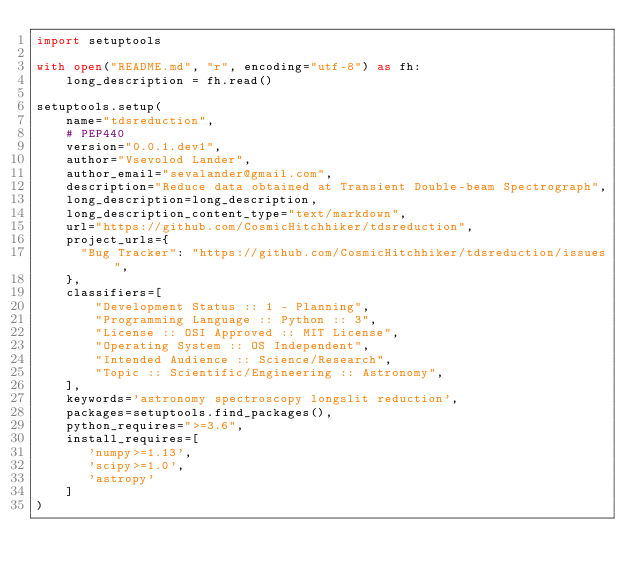<code> <loc_0><loc_0><loc_500><loc_500><_Python_>import setuptools

with open("README.md", "r", encoding="utf-8") as fh:
    long_description = fh.read()

setuptools.setup(
    name="tdsreduction",
    # PEP440
    version="0.0.1.dev1",
    author="Vsevolod Lander",
    author_email="sevalander@gmail.com",
    description="Reduce data obtained at Transient Double-beam Spectrograph",
    long_description=long_description,
    long_description_content_type="text/markdown",
    url="https://github.com/CosmicHitchhiker/tdsreduction",
    project_urls={
      "Bug Tracker": "https://github.com/CosmicHitchhiker/tdsreduction/issues",
    },
    classifiers=[
        "Development Status :: 1 - Planning",
        "Programming Language :: Python :: 3",
        "License :: OSI Approved :: MIT License",
        "Operating System :: OS Independent",
        "Intended Audience :: Science/Research",
        "Topic :: Scientific/Engineering :: Astronomy",
    ],
    keywords='astronomy spectroscopy longslit reduction',
    packages=setuptools.find_packages(),
    python_requires=">=3.6",
    install_requires=[
       'numpy>=1.13',
       'scipy>=1.0',
       'astropy'
    ]
)
</code> 